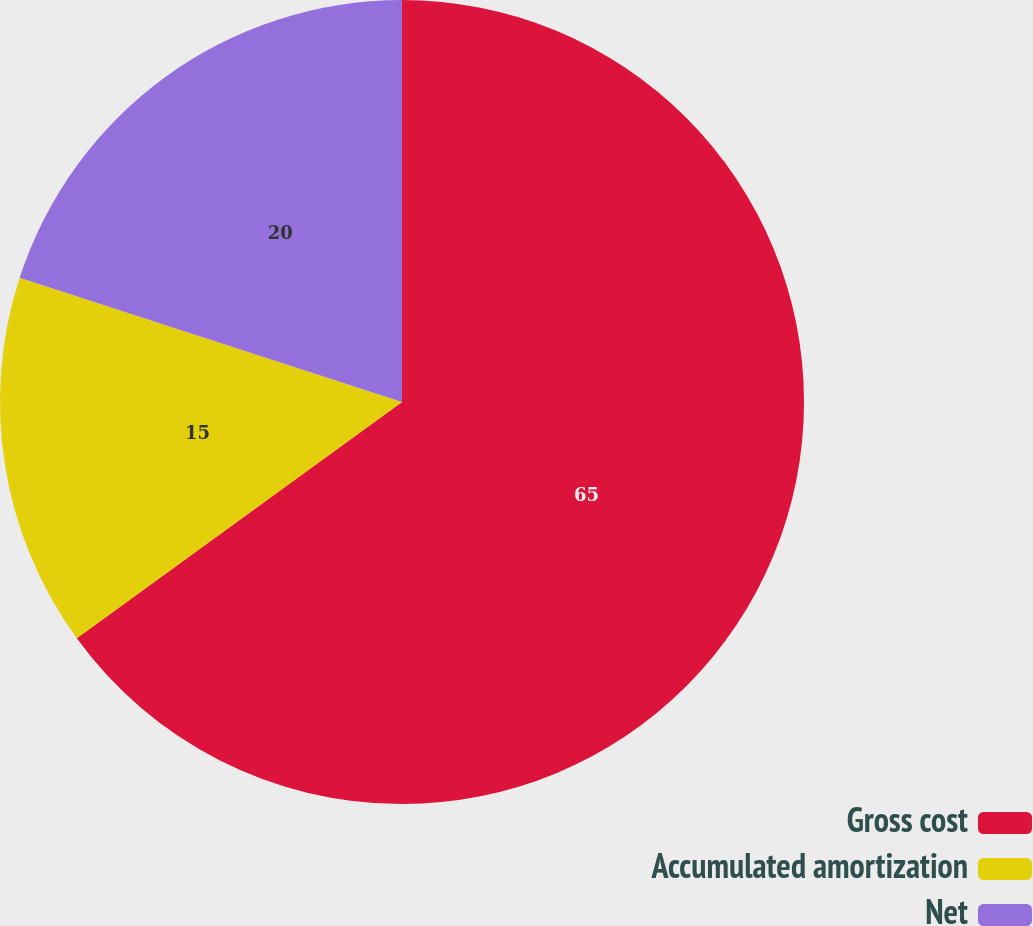Convert chart to OTSL. <chart><loc_0><loc_0><loc_500><loc_500><pie_chart><fcel>Gross cost<fcel>Accumulated amortization<fcel>Net<nl><fcel>65.0%<fcel>15.0%<fcel>20.0%<nl></chart> 